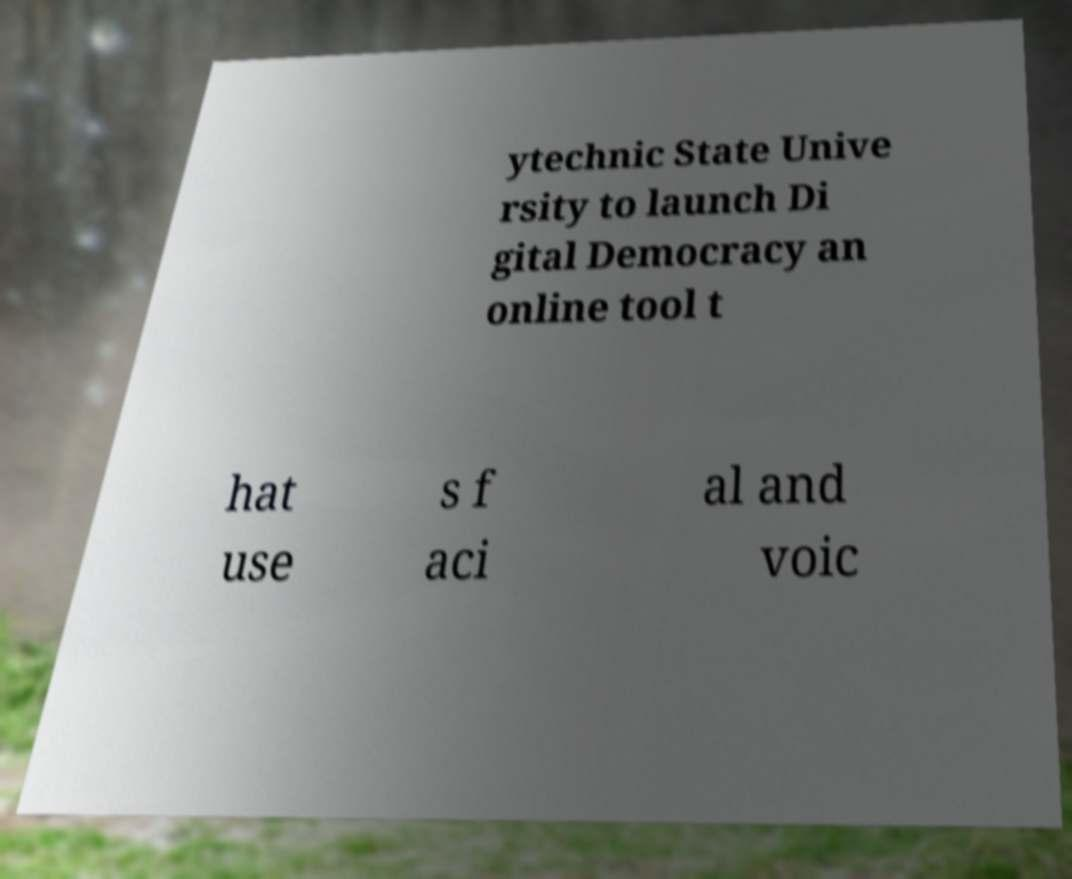Can you accurately transcribe the text from the provided image for me? ytechnic State Unive rsity to launch Di gital Democracy an online tool t hat use s f aci al and voic 